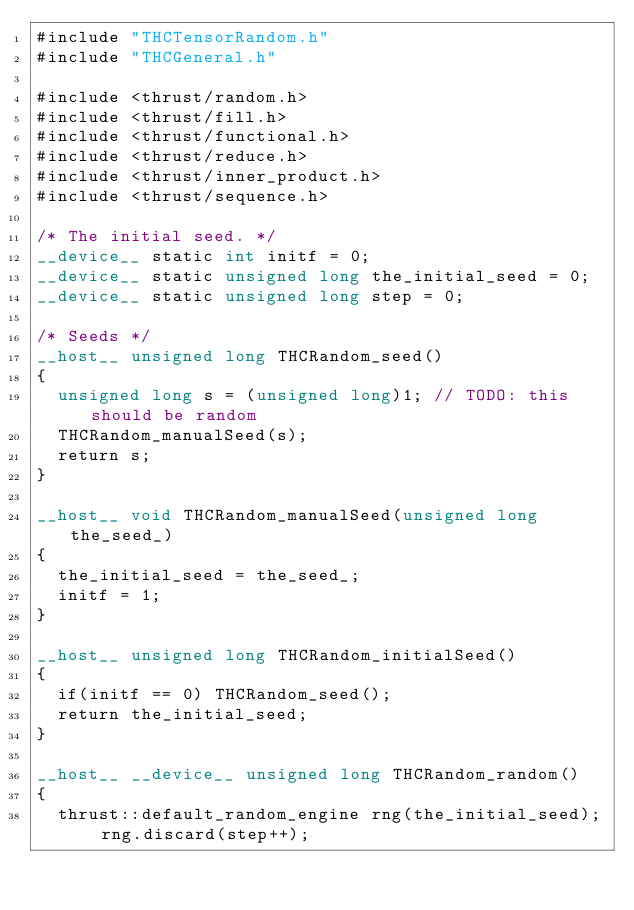Convert code to text. <code><loc_0><loc_0><loc_500><loc_500><_Cuda_>#include "THCTensorRandom.h"
#include "THCGeneral.h"

#include <thrust/random.h>
#include <thrust/fill.h>
#include <thrust/functional.h>
#include <thrust/reduce.h>
#include <thrust/inner_product.h>
#include <thrust/sequence.h>

/* The initial seed. */
__device__ static int initf = 0;
__device__ static unsigned long the_initial_seed = 0;
__device__ static unsigned long step = 0;

/* Seeds */
__host__ unsigned long THCRandom_seed()
{
  unsigned long s = (unsigned long)1; // TODO: this should be random
  THCRandom_manualSeed(s);
  return s;
}

__host__ void THCRandom_manualSeed(unsigned long the_seed_)
{
  the_initial_seed = the_seed_;
  initf = 1;
}

__host__ unsigned long THCRandom_initialSeed()
{
  if(initf == 0) THCRandom_seed();
  return the_initial_seed;
}

__host__ __device__ unsigned long THCRandom_random()
{
  thrust::default_random_engine rng(the_initial_seed); rng.discard(step++);</code> 